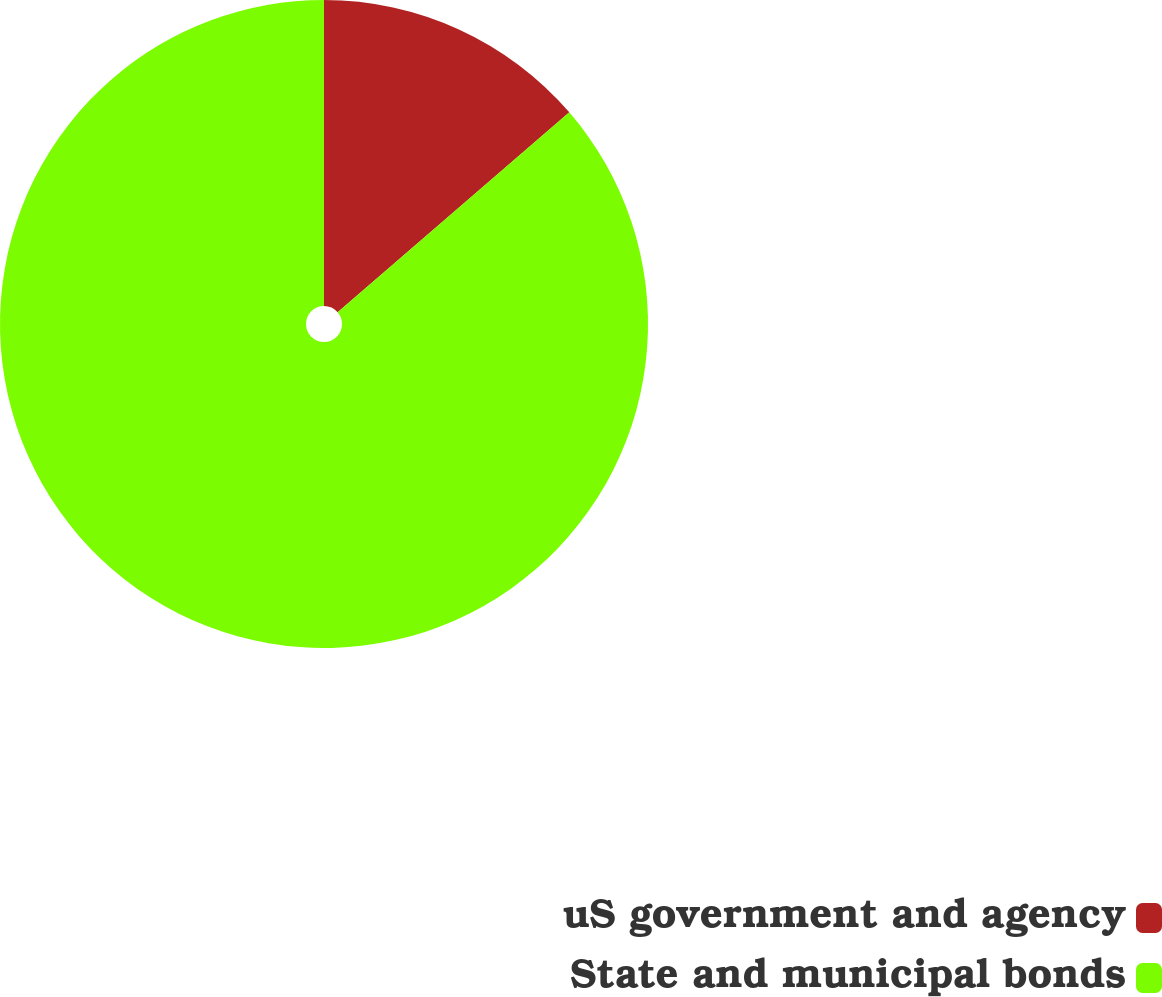Convert chart. <chart><loc_0><loc_0><loc_500><loc_500><pie_chart><fcel>uS government and agency<fcel>State and municipal bonds<nl><fcel>13.67%<fcel>86.33%<nl></chart> 